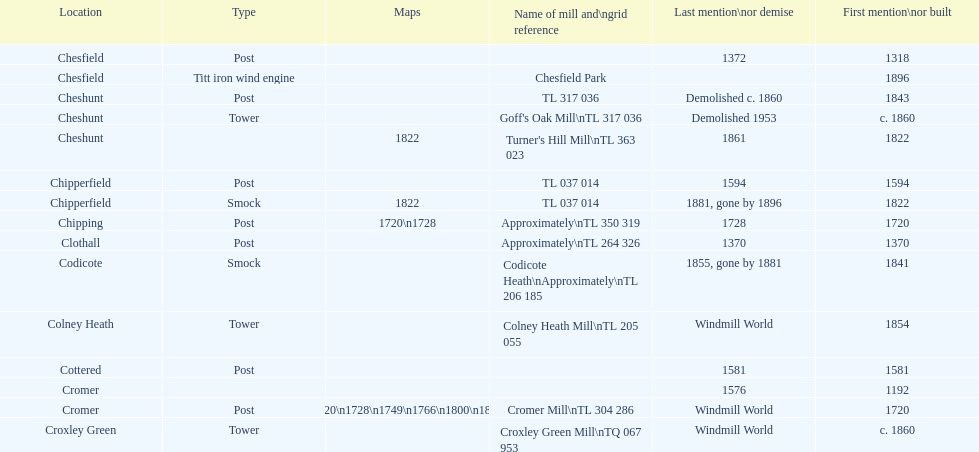How many mills were built or first mentioned after 1800? 8. 